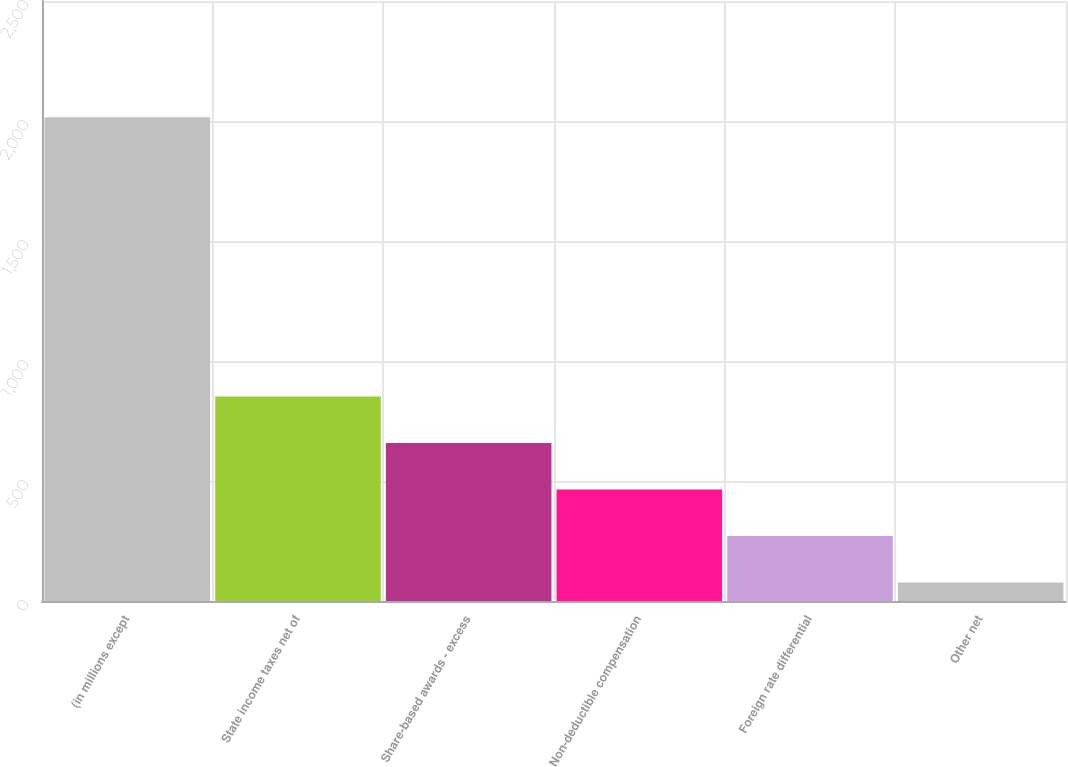<chart> <loc_0><loc_0><loc_500><loc_500><bar_chart><fcel>(in millions except<fcel>State income taxes net of<fcel>Share-based awards - excess<fcel>Non-deductible compensation<fcel>Foreign rate differential<fcel>Other net<nl><fcel>2016<fcel>852.6<fcel>658.7<fcel>464.8<fcel>270.9<fcel>77<nl></chart> 